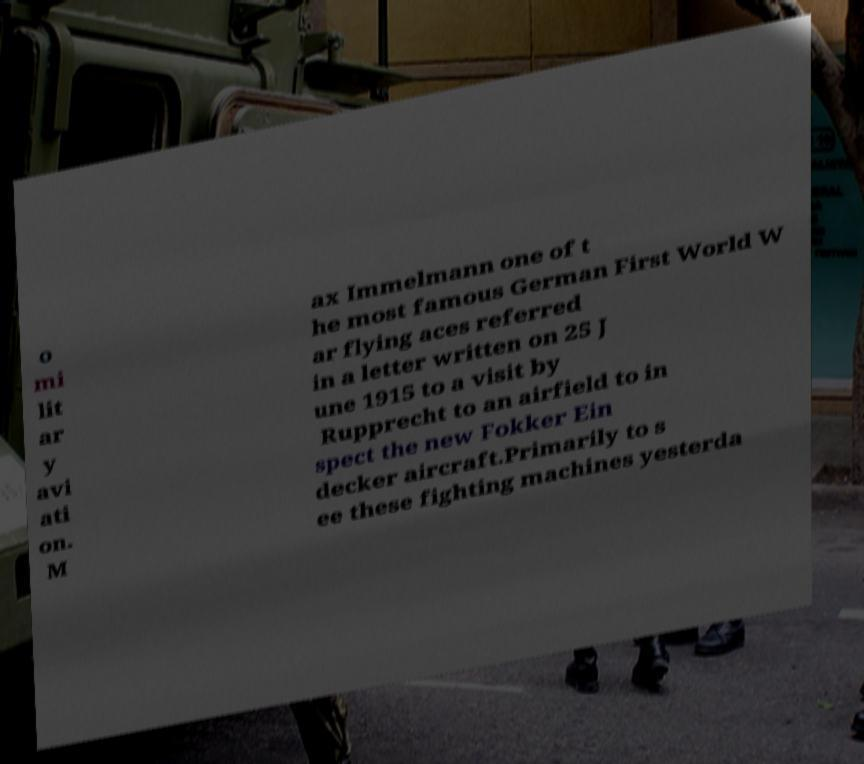Please identify and transcribe the text found in this image. o mi lit ar y avi ati on. M ax Immelmann one of t he most famous German First World W ar flying aces referred in a letter written on 25 J une 1915 to a visit by Rupprecht to an airfield to in spect the new Fokker Ein decker aircraft.Primarily to s ee these fighting machines yesterda 